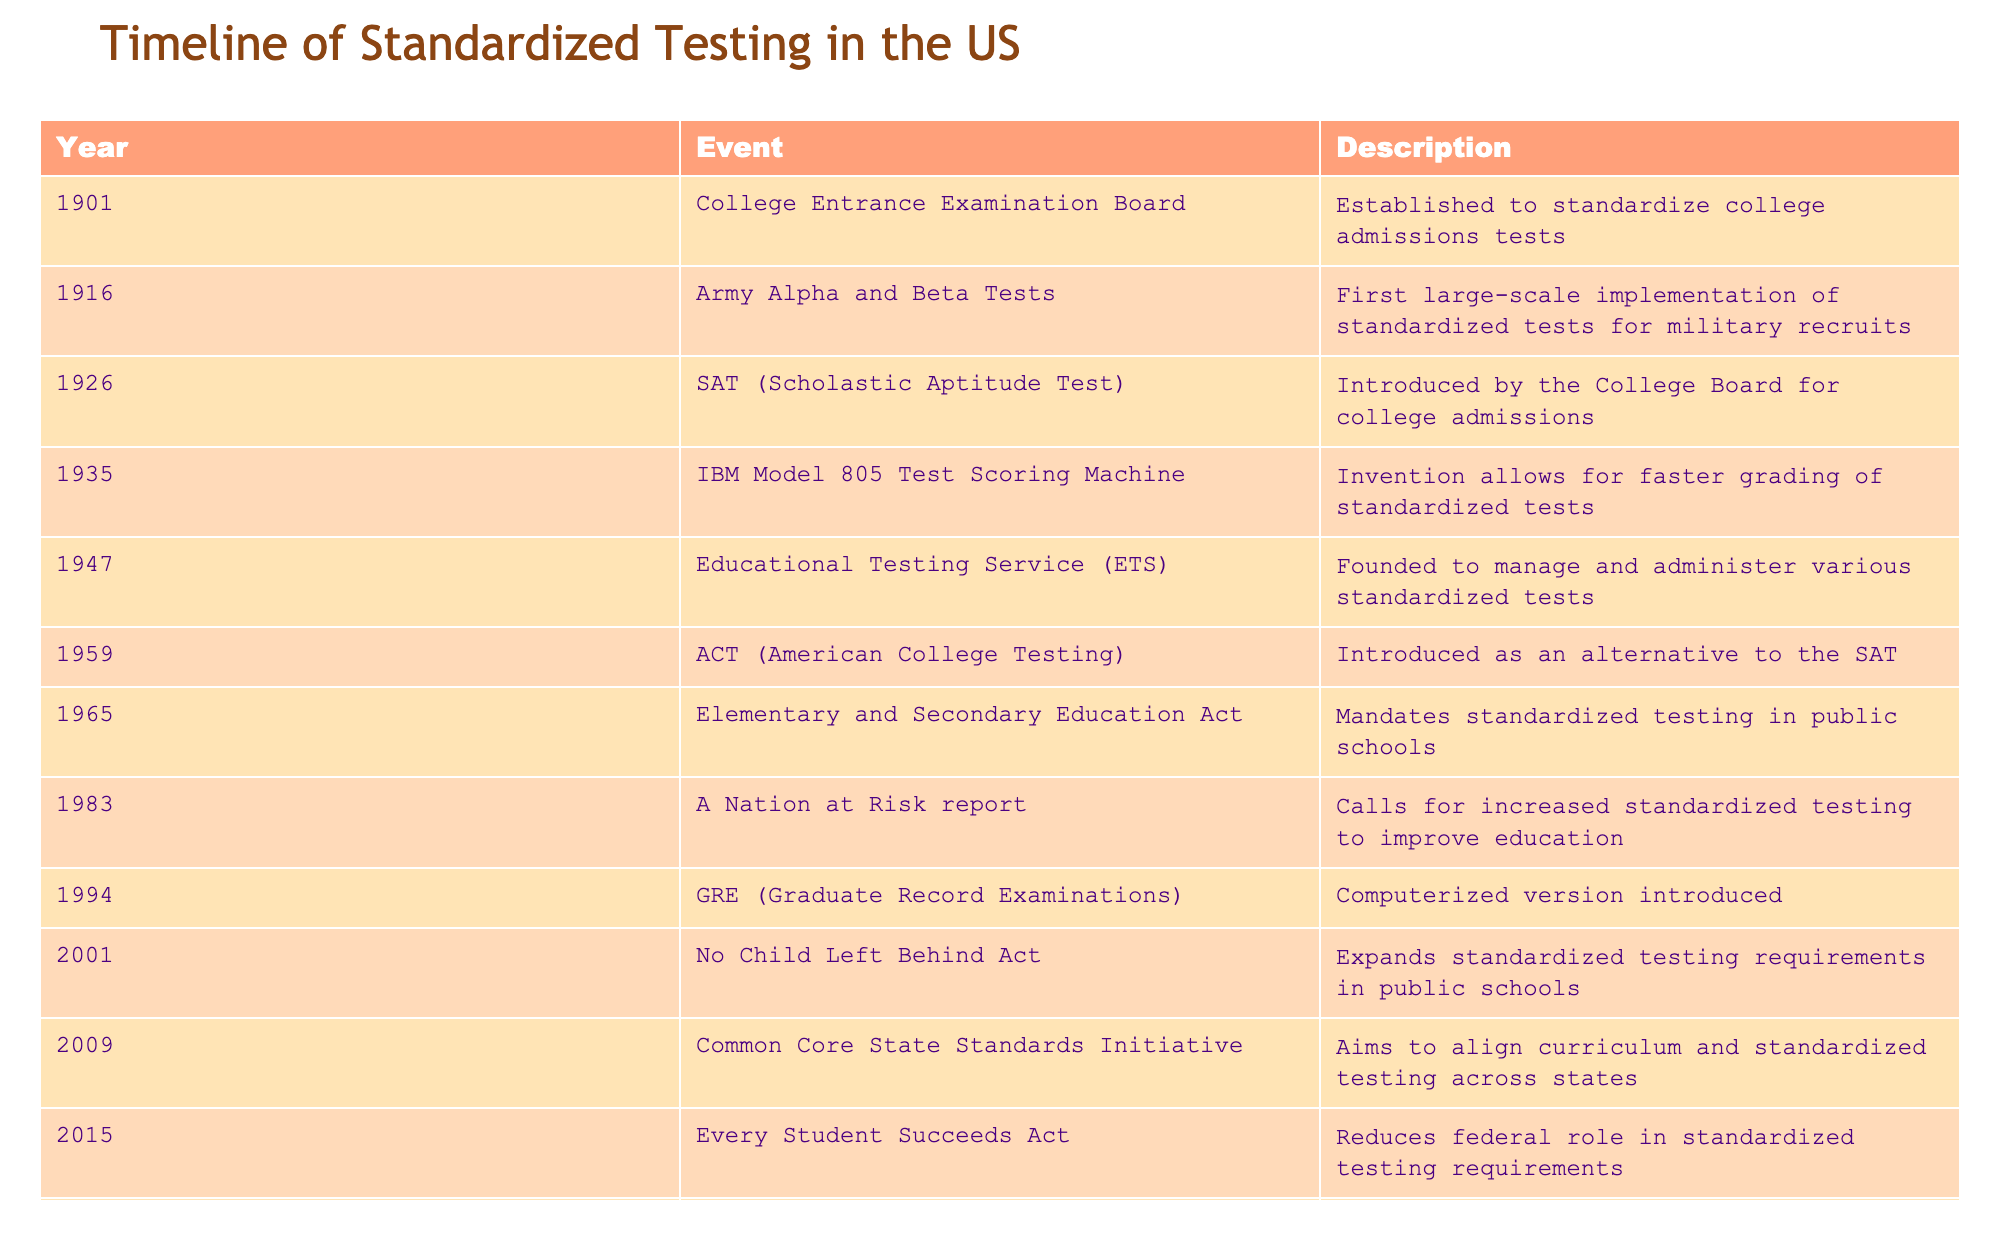What year was the SAT introduced? The SAT was introduced in 1926, as shown in the table where the event and description specifically state the year it was launched.
Answer: 1926 Which event marks the establishment of the Educational Testing Service? The Educational Testing Service (ETS) was founded in 1947, which is explicitly listed in the event and description columns in the table.
Answer: 1947 Was the Army Alpha and Beta Tests the first implementation of standardized tests? Yes, the Army Alpha and Beta Tests, introduced in 1916, are described as the first large-scale implementation of standardized tests for military recruits.
Answer: Yes What is the range of years during which standardized testing was significantly expanded in the U.S.? The years of significant expansion are from 1965 (Elementary and Secondary Education Act) to 2009 (No Child Left Behind Act), highlighting a 44-year range of growth in standardized testing requirements.
Answer: 1965-2009 How many standardized testing milestones occurred before the year 2000? By counting the events before the year 2000 in the provided timeline, there are 8 milestones listed from 1901 to 1994.
Answer: 8 What significant event in 1983 called for increased standardized testing? The "A Nation at Risk" report released in 1983 specifically called for increased standardized testing in education as captured in the description of the table.
Answer: A Nation at Risk report Which two events are closely related to the College Board? The events related to the College Board are the establishment of the College Entrance Examination Board in 1901 and the introduction of the SAT in 1926, both of which are directly attributed to the College Board in the descriptions.
Answer: College Entrance Examination Board and SAT What notable development occurred in the GED in the 1990s? The introduction of the computerized version of the GRE in 1994 represents the notable development in standardized testing during the 1990s according to the table.
Answer: Computerized GRE Which act reduced the federal role in standardized testing requirements, and when was it enacted? The Every Student Succeeds Act enacted in 2015 is mentioned in the table as the act that reduced the federal role in standardized testing requirements.
Answer: Every Student Succeeds Act, 2015 